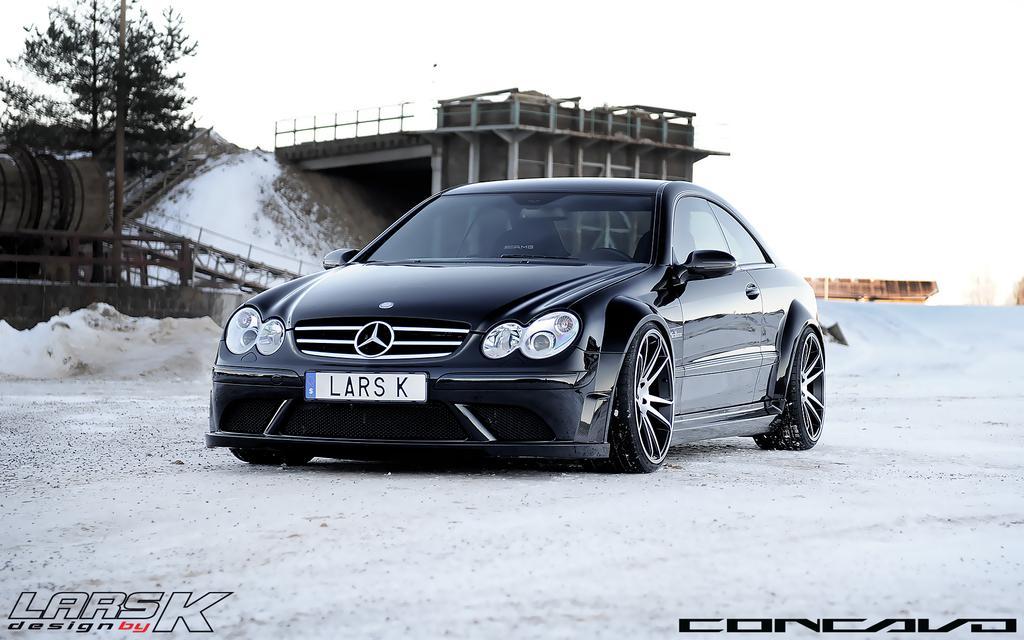Can you describe this image briefly? We can see car on the road. In the background we can see tree,pole,wall and it is white color. 